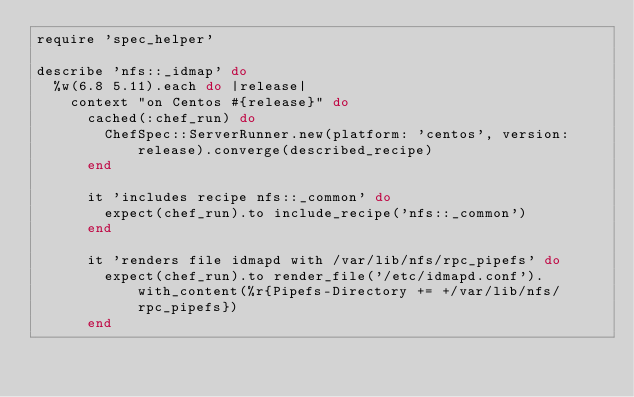Convert code to text. <code><loc_0><loc_0><loc_500><loc_500><_Ruby_>require 'spec_helper'

describe 'nfs::_idmap' do
  %w(6.8 5.11).each do |release|
    context "on Centos #{release}" do
      cached(:chef_run) do
        ChefSpec::ServerRunner.new(platform: 'centos', version: release).converge(described_recipe)
      end

      it 'includes recipe nfs::_common' do
        expect(chef_run).to include_recipe('nfs::_common')
      end

      it 'renders file idmapd with /var/lib/nfs/rpc_pipefs' do
        expect(chef_run).to render_file('/etc/idmapd.conf').with_content(%r{Pipefs-Directory += +/var/lib/nfs/rpc_pipefs})
      end
</code> 